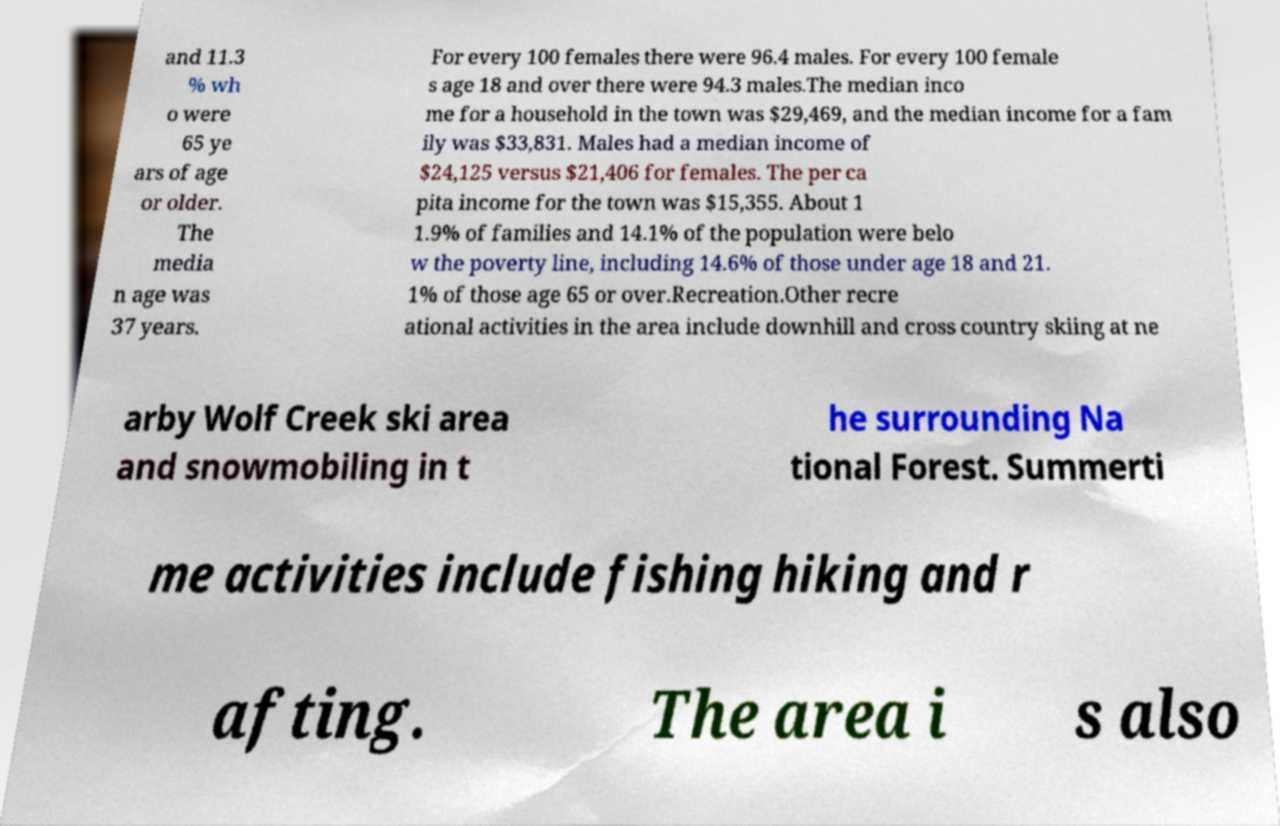There's text embedded in this image that I need extracted. Can you transcribe it verbatim? and 11.3 % wh o were 65 ye ars of age or older. The media n age was 37 years. For every 100 females there were 96.4 males. For every 100 female s age 18 and over there were 94.3 males.The median inco me for a household in the town was $29,469, and the median income for a fam ily was $33,831. Males had a median income of $24,125 versus $21,406 for females. The per ca pita income for the town was $15,355. About 1 1.9% of families and 14.1% of the population were belo w the poverty line, including 14.6% of those under age 18 and 21. 1% of those age 65 or over.Recreation.Other recre ational activities in the area include downhill and cross country skiing at ne arby Wolf Creek ski area and snowmobiling in t he surrounding Na tional Forest. Summerti me activities include fishing hiking and r afting. The area i s also 